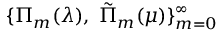<formula> <loc_0><loc_0><loc_500><loc_500>\{ \Pi _ { m } ( \lambda ) , \, \tilde { \Pi } _ { m } ( \mu ) \} _ { m = 0 } ^ { \infty }</formula> 